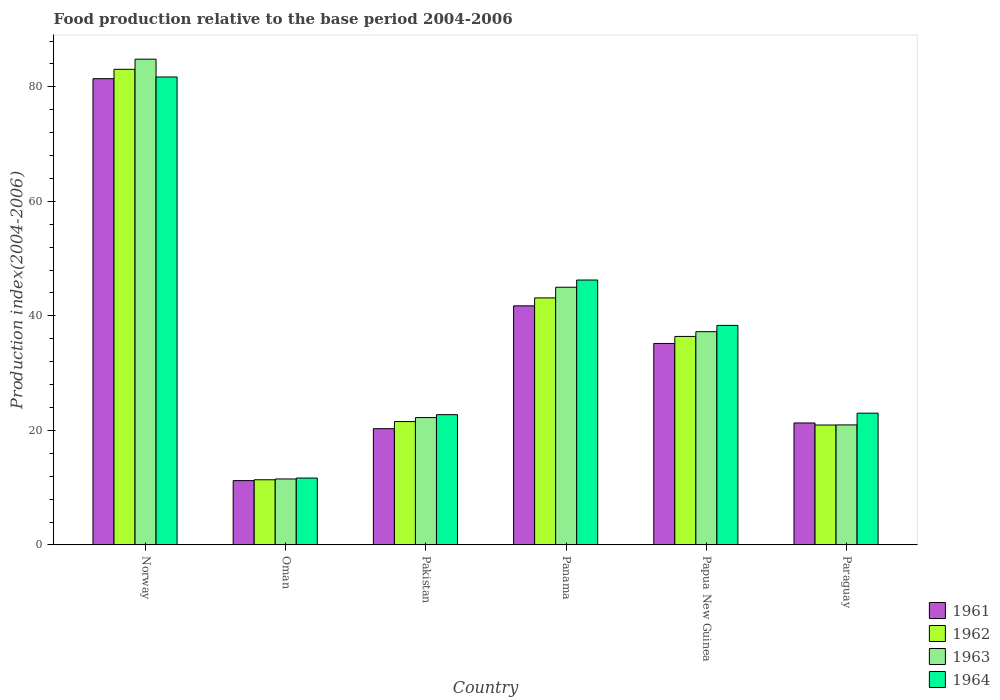How many groups of bars are there?
Make the answer very short. 6. Are the number of bars per tick equal to the number of legend labels?
Make the answer very short. Yes. Are the number of bars on each tick of the X-axis equal?
Offer a terse response. Yes. How many bars are there on the 6th tick from the right?
Provide a succinct answer. 4. In how many cases, is the number of bars for a given country not equal to the number of legend labels?
Your response must be concise. 0. What is the food production index in 1963 in Pakistan?
Give a very brief answer. 22.24. Across all countries, what is the maximum food production index in 1962?
Your response must be concise. 83.06. Across all countries, what is the minimum food production index in 1963?
Give a very brief answer. 11.52. In which country was the food production index in 1964 minimum?
Provide a succinct answer. Oman. What is the total food production index in 1964 in the graph?
Offer a terse response. 223.76. What is the difference between the food production index in 1961 in Norway and that in Panama?
Keep it short and to the point. 39.67. What is the difference between the food production index in 1963 in Papua New Guinea and the food production index in 1961 in Norway?
Ensure brevity in your answer.  -44.18. What is the average food production index in 1963 per country?
Your answer should be compact. 36.96. What is the difference between the food production index of/in 1962 and food production index of/in 1963 in Papua New Guinea?
Keep it short and to the point. -0.83. In how many countries, is the food production index in 1963 greater than 72?
Offer a very short reply. 1. What is the ratio of the food production index in 1964 in Pakistan to that in Paraguay?
Make the answer very short. 0.99. What is the difference between the highest and the second highest food production index in 1964?
Give a very brief answer. -43.38. What is the difference between the highest and the lowest food production index in 1964?
Offer a terse response. 70.04. In how many countries, is the food production index in 1964 greater than the average food production index in 1964 taken over all countries?
Your response must be concise. 3. Is it the case that in every country, the sum of the food production index in 1962 and food production index in 1963 is greater than the sum of food production index in 1961 and food production index in 1964?
Provide a succinct answer. No. What does the 1st bar from the left in Pakistan represents?
Your answer should be very brief. 1961. Is it the case that in every country, the sum of the food production index in 1963 and food production index in 1962 is greater than the food production index in 1961?
Make the answer very short. Yes. Are the values on the major ticks of Y-axis written in scientific E-notation?
Ensure brevity in your answer.  No. How are the legend labels stacked?
Ensure brevity in your answer.  Vertical. What is the title of the graph?
Offer a terse response. Food production relative to the base period 2004-2006. What is the label or title of the Y-axis?
Give a very brief answer. Production index(2004-2006). What is the Production index(2004-2006) in 1961 in Norway?
Offer a terse response. 81.42. What is the Production index(2004-2006) in 1962 in Norway?
Provide a succinct answer. 83.06. What is the Production index(2004-2006) in 1963 in Norway?
Keep it short and to the point. 84.83. What is the Production index(2004-2006) of 1964 in Norway?
Ensure brevity in your answer.  81.72. What is the Production index(2004-2006) in 1961 in Oman?
Give a very brief answer. 11.23. What is the Production index(2004-2006) of 1962 in Oman?
Offer a very short reply. 11.38. What is the Production index(2004-2006) of 1963 in Oman?
Your answer should be very brief. 11.52. What is the Production index(2004-2006) of 1964 in Oman?
Provide a succinct answer. 11.68. What is the Production index(2004-2006) of 1961 in Pakistan?
Provide a succinct answer. 20.3. What is the Production index(2004-2006) in 1962 in Pakistan?
Keep it short and to the point. 21.54. What is the Production index(2004-2006) of 1963 in Pakistan?
Provide a short and direct response. 22.24. What is the Production index(2004-2006) of 1964 in Pakistan?
Keep it short and to the point. 22.75. What is the Production index(2004-2006) of 1961 in Panama?
Provide a short and direct response. 41.75. What is the Production index(2004-2006) of 1962 in Panama?
Your response must be concise. 43.14. What is the Production index(2004-2006) of 1963 in Panama?
Provide a short and direct response. 45. What is the Production index(2004-2006) of 1964 in Panama?
Your answer should be compact. 46.26. What is the Production index(2004-2006) of 1961 in Papua New Guinea?
Provide a short and direct response. 35.18. What is the Production index(2004-2006) in 1962 in Papua New Guinea?
Make the answer very short. 36.41. What is the Production index(2004-2006) of 1963 in Papua New Guinea?
Your response must be concise. 37.24. What is the Production index(2004-2006) of 1964 in Papua New Guinea?
Your answer should be compact. 38.34. What is the Production index(2004-2006) in 1961 in Paraguay?
Give a very brief answer. 21.3. What is the Production index(2004-2006) in 1962 in Paraguay?
Provide a short and direct response. 20.94. What is the Production index(2004-2006) of 1963 in Paraguay?
Ensure brevity in your answer.  20.96. What is the Production index(2004-2006) in 1964 in Paraguay?
Provide a succinct answer. 23.01. Across all countries, what is the maximum Production index(2004-2006) in 1961?
Offer a very short reply. 81.42. Across all countries, what is the maximum Production index(2004-2006) of 1962?
Your answer should be very brief. 83.06. Across all countries, what is the maximum Production index(2004-2006) in 1963?
Give a very brief answer. 84.83. Across all countries, what is the maximum Production index(2004-2006) in 1964?
Offer a very short reply. 81.72. Across all countries, what is the minimum Production index(2004-2006) of 1961?
Offer a very short reply. 11.23. Across all countries, what is the minimum Production index(2004-2006) in 1962?
Ensure brevity in your answer.  11.38. Across all countries, what is the minimum Production index(2004-2006) of 1963?
Your response must be concise. 11.52. Across all countries, what is the minimum Production index(2004-2006) in 1964?
Make the answer very short. 11.68. What is the total Production index(2004-2006) of 1961 in the graph?
Your answer should be compact. 211.18. What is the total Production index(2004-2006) in 1962 in the graph?
Keep it short and to the point. 216.47. What is the total Production index(2004-2006) in 1963 in the graph?
Offer a terse response. 221.79. What is the total Production index(2004-2006) of 1964 in the graph?
Your answer should be very brief. 223.76. What is the difference between the Production index(2004-2006) of 1961 in Norway and that in Oman?
Ensure brevity in your answer.  70.19. What is the difference between the Production index(2004-2006) of 1962 in Norway and that in Oman?
Provide a succinct answer. 71.68. What is the difference between the Production index(2004-2006) in 1963 in Norway and that in Oman?
Keep it short and to the point. 73.31. What is the difference between the Production index(2004-2006) of 1964 in Norway and that in Oman?
Offer a very short reply. 70.04. What is the difference between the Production index(2004-2006) of 1961 in Norway and that in Pakistan?
Provide a succinct answer. 61.12. What is the difference between the Production index(2004-2006) in 1962 in Norway and that in Pakistan?
Your answer should be compact. 61.52. What is the difference between the Production index(2004-2006) of 1963 in Norway and that in Pakistan?
Provide a succinct answer. 62.59. What is the difference between the Production index(2004-2006) of 1964 in Norway and that in Pakistan?
Provide a succinct answer. 58.97. What is the difference between the Production index(2004-2006) of 1961 in Norway and that in Panama?
Keep it short and to the point. 39.67. What is the difference between the Production index(2004-2006) of 1962 in Norway and that in Panama?
Give a very brief answer. 39.92. What is the difference between the Production index(2004-2006) of 1963 in Norway and that in Panama?
Ensure brevity in your answer.  39.83. What is the difference between the Production index(2004-2006) in 1964 in Norway and that in Panama?
Provide a succinct answer. 35.46. What is the difference between the Production index(2004-2006) in 1961 in Norway and that in Papua New Guinea?
Provide a short and direct response. 46.24. What is the difference between the Production index(2004-2006) in 1962 in Norway and that in Papua New Guinea?
Ensure brevity in your answer.  46.65. What is the difference between the Production index(2004-2006) in 1963 in Norway and that in Papua New Guinea?
Make the answer very short. 47.59. What is the difference between the Production index(2004-2006) of 1964 in Norway and that in Papua New Guinea?
Offer a very short reply. 43.38. What is the difference between the Production index(2004-2006) of 1961 in Norway and that in Paraguay?
Offer a terse response. 60.12. What is the difference between the Production index(2004-2006) of 1962 in Norway and that in Paraguay?
Offer a very short reply. 62.12. What is the difference between the Production index(2004-2006) of 1963 in Norway and that in Paraguay?
Keep it short and to the point. 63.87. What is the difference between the Production index(2004-2006) of 1964 in Norway and that in Paraguay?
Your response must be concise. 58.71. What is the difference between the Production index(2004-2006) in 1961 in Oman and that in Pakistan?
Your answer should be very brief. -9.07. What is the difference between the Production index(2004-2006) of 1962 in Oman and that in Pakistan?
Provide a short and direct response. -10.16. What is the difference between the Production index(2004-2006) of 1963 in Oman and that in Pakistan?
Your answer should be very brief. -10.72. What is the difference between the Production index(2004-2006) in 1964 in Oman and that in Pakistan?
Offer a terse response. -11.07. What is the difference between the Production index(2004-2006) in 1961 in Oman and that in Panama?
Provide a short and direct response. -30.52. What is the difference between the Production index(2004-2006) in 1962 in Oman and that in Panama?
Your response must be concise. -31.76. What is the difference between the Production index(2004-2006) of 1963 in Oman and that in Panama?
Offer a terse response. -33.48. What is the difference between the Production index(2004-2006) in 1964 in Oman and that in Panama?
Provide a short and direct response. -34.58. What is the difference between the Production index(2004-2006) in 1961 in Oman and that in Papua New Guinea?
Ensure brevity in your answer.  -23.95. What is the difference between the Production index(2004-2006) in 1962 in Oman and that in Papua New Guinea?
Offer a very short reply. -25.03. What is the difference between the Production index(2004-2006) in 1963 in Oman and that in Papua New Guinea?
Your answer should be compact. -25.72. What is the difference between the Production index(2004-2006) in 1964 in Oman and that in Papua New Guinea?
Your answer should be very brief. -26.66. What is the difference between the Production index(2004-2006) in 1961 in Oman and that in Paraguay?
Your answer should be very brief. -10.07. What is the difference between the Production index(2004-2006) in 1962 in Oman and that in Paraguay?
Ensure brevity in your answer.  -9.56. What is the difference between the Production index(2004-2006) in 1963 in Oman and that in Paraguay?
Your answer should be very brief. -9.44. What is the difference between the Production index(2004-2006) of 1964 in Oman and that in Paraguay?
Keep it short and to the point. -11.33. What is the difference between the Production index(2004-2006) of 1961 in Pakistan and that in Panama?
Provide a short and direct response. -21.45. What is the difference between the Production index(2004-2006) in 1962 in Pakistan and that in Panama?
Keep it short and to the point. -21.6. What is the difference between the Production index(2004-2006) of 1963 in Pakistan and that in Panama?
Offer a terse response. -22.76. What is the difference between the Production index(2004-2006) in 1964 in Pakistan and that in Panama?
Give a very brief answer. -23.51. What is the difference between the Production index(2004-2006) of 1961 in Pakistan and that in Papua New Guinea?
Keep it short and to the point. -14.88. What is the difference between the Production index(2004-2006) of 1962 in Pakistan and that in Papua New Guinea?
Your answer should be compact. -14.87. What is the difference between the Production index(2004-2006) in 1964 in Pakistan and that in Papua New Guinea?
Your answer should be compact. -15.59. What is the difference between the Production index(2004-2006) of 1961 in Pakistan and that in Paraguay?
Keep it short and to the point. -1. What is the difference between the Production index(2004-2006) of 1962 in Pakistan and that in Paraguay?
Give a very brief answer. 0.6. What is the difference between the Production index(2004-2006) of 1963 in Pakistan and that in Paraguay?
Offer a very short reply. 1.28. What is the difference between the Production index(2004-2006) of 1964 in Pakistan and that in Paraguay?
Your response must be concise. -0.26. What is the difference between the Production index(2004-2006) in 1961 in Panama and that in Papua New Guinea?
Your response must be concise. 6.57. What is the difference between the Production index(2004-2006) in 1962 in Panama and that in Papua New Guinea?
Offer a terse response. 6.73. What is the difference between the Production index(2004-2006) of 1963 in Panama and that in Papua New Guinea?
Make the answer very short. 7.76. What is the difference between the Production index(2004-2006) in 1964 in Panama and that in Papua New Guinea?
Provide a succinct answer. 7.92. What is the difference between the Production index(2004-2006) of 1961 in Panama and that in Paraguay?
Your answer should be very brief. 20.45. What is the difference between the Production index(2004-2006) in 1962 in Panama and that in Paraguay?
Make the answer very short. 22.2. What is the difference between the Production index(2004-2006) in 1963 in Panama and that in Paraguay?
Provide a succinct answer. 24.04. What is the difference between the Production index(2004-2006) in 1964 in Panama and that in Paraguay?
Provide a short and direct response. 23.25. What is the difference between the Production index(2004-2006) in 1961 in Papua New Guinea and that in Paraguay?
Your answer should be very brief. 13.88. What is the difference between the Production index(2004-2006) of 1962 in Papua New Guinea and that in Paraguay?
Make the answer very short. 15.47. What is the difference between the Production index(2004-2006) of 1963 in Papua New Guinea and that in Paraguay?
Offer a terse response. 16.28. What is the difference between the Production index(2004-2006) of 1964 in Papua New Guinea and that in Paraguay?
Your response must be concise. 15.33. What is the difference between the Production index(2004-2006) of 1961 in Norway and the Production index(2004-2006) of 1962 in Oman?
Ensure brevity in your answer.  70.04. What is the difference between the Production index(2004-2006) of 1961 in Norway and the Production index(2004-2006) of 1963 in Oman?
Provide a short and direct response. 69.9. What is the difference between the Production index(2004-2006) in 1961 in Norway and the Production index(2004-2006) in 1964 in Oman?
Ensure brevity in your answer.  69.74. What is the difference between the Production index(2004-2006) in 1962 in Norway and the Production index(2004-2006) in 1963 in Oman?
Your response must be concise. 71.54. What is the difference between the Production index(2004-2006) of 1962 in Norway and the Production index(2004-2006) of 1964 in Oman?
Your answer should be compact. 71.38. What is the difference between the Production index(2004-2006) of 1963 in Norway and the Production index(2004-2006) of 1964 in Oman?
Provide a short and direct response. 73.15. What is the difference between the Production index(2004-2006) in 1961 in Norway and the Production index(2004-2006) in 1962 in Pakistan?
Offer a terse response. 59.88. What is the difference between the Production index(2004-2006) in 1961 in Norway and the Production index(2004-2006) in 1963 in Pakistan?
Keep it short and to the point. 59.18. What is the difference between the Production index(2004-2006) in 1961 in Norway and the Production index(2004-2006) in 1964 in Pakistan?
Ensure brevity in your answer.  58.67. What is the difference between the Production index(2004-2006) of 1962 in Norway and the Production index(2004-2006) of 1963 in Pakistan?
Ensure brevity in your answer.  60.82. What is the difference between the Production index(2004-2006) in 1962 in Norway and the Production index(2004-2006) in 1964 in Pakistan?
Keep it short and to the point. 60.31. What is the difference between the Production index(2004-2006) in 1963 in Norway and the Production index(2004-2006) in 1964 in Pakistan?
Offer a terse response. 62.08. What is the difference between the Production index(2004-2006) in 1961 in Norway and the Production index(2004-2006) in 1962 in Panama?
Your answer should be very brief. 38.28. What is the difference between the Production index(2004-2006) of 1961 in Norway and the Production index(2004-2006) of 1963 in Panama?
Your response must be concise. 36.42. What is the difference between the Production index(2004-2006) of 1961 in Norway and the Production index(2004-2006) of 1964 in Panama?
Ensure brevity in your answer.  35.16. What is the difference between the Production index(2004-2006) of 1962 in Norway and the Production index(2004-2006) of 1963 in Panama?
Ensure brevity in your answer.  38.06. What is the difference between the Production index(2004-2006) in 1962 in Norway and the Production index(2004-2006) in 1964 in Panama?
Your answer should be compact. 36.8. What is the difference between the Production index(2004-2006) in 1963 in Norway and the Production index(2004-2006) in 1964 in Panama?
Your answer should be very brief. 38.57. What is the difference between the Production index(2004-2006) of 1961 in Norway and the Production index(2004-2006) of 1962 in Papua New Guinea?
Your answer should be very brief. 45.01. What is the difference between the Production index(2004-2006) in 1961 in Norway and the Production index(2004-2006) in 1963 in Papua New Guinea?
Your response must be concise. 44.18. What is the difference between the Production index(2004-2006) in 1961 in Norway and the Production index(2004-2006) in 1964 in Papua New Guinea?
Make the answer very short. 43.08. What is the difference between the Production index(2004-2006) of 1962 in Norway and the Production index(2004-2006) of 1963 in Papua New Guinea?
Provide a short and direct response. 45.82. What is the difference between the Production index(2004-2006) of 1962 in Norway and the Production index(2004-2006) of 1964 in Papua New Guinea?
Provide a succinct answer. 44.72. What is the difference between the Production index(2004-2006) of 1963 in Norway and the Production index(2004-2006) of 1964 in Papua New Guinea?
Keep it short and to the point. 46.49. What is the difference between the Production index(2004-2006) in 1961 in Norway and the Production index(2004-2006) in 1962 in Paraguay?
Your response must be concise. 60.48. What is the difference between the Production index(2004-2006) in 1961 in Norway and the Production index(2004-2006) in 1963 in Paraguay?
Your answer should be compact. 60.46. What is the difference between the Production index(2004-2006) in 1961 in Norway and the Production index(2004-2006) in 1964 in Paraguay?
Provide a short and direct response. 58.41. What is the difference between the Production index(2004-2006) in 1962 in Norway and the Production index(2004-2006) in 1963 in Paraguay?
Provide a short and direct response. 62.1. What is the difference between the Production index(2004-2006) of 1962 in Norway and the Production index(2004-2006) of 1964 in Paraguay?
Your answer should be very brief. 60.05. What is the difference between the Production index(2004-2006) in 1963 in Norway and the Production index(2004-2006) in 1964 in Paraguay?
Give a very brief answer. 61.82. What is the difference between the Production index(2004-2006) of 1961 in Oman and the Production index(2004-2006) of 1962 in Pakistan?
Your response must be concise. -10.31. What is the difference between the Production index(2004-2006) of 1961 in Oman and the Production index(2004-2006) of 1963 in Pakistan?
Your answer should be very brief. -11.01. What is the difference between the Production index(2004-2006) in 1961 in Oman and the Production index(2004-2006) in 1964 in Pakistan?
Provide a short and direct response. -11.52. What is the difference between the Production index(2004-2006) in 1962 in Oman and the Production index(2004-2006) in 1963 in Pakistan?
Provide a succinct answer. -10.86. What is the difference between the Production index(2004-2006) of 1962 in Oman and the Production index(2004-2006) of 1964 in Pakistan?
Keep it short and to the point. -11.37. What is the difference between the Production index(2004-2006) of 1963 in Oman and the Production index(2004-2006) of 1964 in Pakistan?
Offer a very short reply. -11.23. What is the difference between the Production index(2004-2006) in 1961 in Oman and the Production index(2004-2006) in 1962 in Panama?
Your response must be concise. -31.91. What is the difference between the Production index(2004-2006) in 1961 in Oman and the Production index(2004-2006) in 1963 in Panama?
Provide a short and direct response. -33.77. What is the difference between the Production index(2004-2006) in 1961 in Oman and the Production index(2004-2006) in 1964 in Panama?
Provide a succinct answer. -35.03. What is the difference between the Production index(2004-2006) of 1962 in Oman and the Production index(2004-2006) of 1963 in Panama?
Give a very brief answer. -33.62. What is the difference between the Production index(2004-2006) in 1962 in Oman and the Production index(2004-2006) in 1964 in Panama?
Provide a succinct answer. -34.88. What is the difference between the Production index(2004-2006) in 1963 in Oman and the Production index(2004-2006) in 1964 in Panama?
Make the answer very short. -34.74. What is the difference between the Production index(2004-2006) in 1961 in Oman and the Production index(2004-2006) in 1962 in Papua New Guinea?
Offer a very short reply. -25.18. What is the difference between the Production index(2004-2006) in 1961 in Oman and the Production index(2004-2006) in 1963 in Papua New Guinea?
Your answer should be very brief. -26.01. What is the difference between the Production index(2004-2006) in 1961 in Oman and the Production index(2004-2006) in 1964 in Papua New Guinea?
Make the answer very short. -27.11. What is the difference between the Production index(2004-2006) in 1962 in Oman and the Production index(2004-2006) in 1963 in Papua New Guinea?
Make the answer very short. -25.86. What is the difference between the Production index(2004-2006) of 1962 in Oman and the Production index(2004-2006) of 1964 in Papua New Guinea?
Keep it short and to the point. -26.96. What is the difference between the Production index(2004-2006) of 1963 in Oman and the Production index(2004-2006) of 1964 in Papua New Guinea?
Offer a very short reply. -26.82. What is the difference between the Production index(2004-2006) in 1961 in Oman and the Production index(2004-2006) in 1962 in Paraguay?
Offer a terse response. -9.71. What is the difference between the Production index(2004-2006) of 1961 in Oman and the Production index(2004-2006) of 1963 in Paraguay?
Offer a very short reply. -9.73. What is the difference between the Production index(2004-2006) of 1961 in Oman and the Production index(2004-2006) of 1964 in Paraguay?
Give a very brief answer. -11.78. What is the difference between the Production index(2004-2006) of 1962 in Oman and the Production index(2004-2006) of 1963 in Paraguay?
Give a very brief answer. -9.58. What is the difference between the Production index(2004-2006) in 1962 in Oman and the Production index(2004-2006) in 1964 in Paraguay?
Provide a short and direct response. -11.63. What is the difference between the Production index(2004-2006) in 1963 in Oman and the Production index(2004-2006) in 1964 in Paraguay?
Provide a succinct answer. -11.49. What is the difference between the Production index(2004-2006) in 1961 in Pakistan and the Production index(2004-2006) in 1962 in Panama?
Ensure brevity in your answer.  -22.84. What is the difference between the Production index(2004-2006) in 1961 in Pakistan and the Production index(2004-2006) in 1963 in Panama?
Provide a succinct answer. -24.7. What is the difference between the Production index(2004-2006) of 1961 in Pakistan and the Production index(2004-2006) of 1964 in Panama?
Provide a short and direct response. -25.96. What is the difference between the Production index(2004-2006) in 1962 in Pakistan and the Production index(2004-2006) in 1963 in Panama?
Give a very brief answer. -23.46. What is the difference between the Production index(2004-2006) in 1962 in Pakistan and the Production index(2004-2006) in 1964 in Panama?
Your answer should be very brief. -24.72. What is the difference between the Production index(2004-2006) in 1963 in Pakistan and the Production index(2004-2006) in 1964 in Panama?
Your response must be concise. -24.02. What is the difference between the Production index(2004-2006) in 1961 in Pakistan and the Production index(2004-2006) in 1962 in Papua New Guinea?
Keep it short and to the point. -16.11. What is the difference between the Production index(2004-2006) of 1961 in Pakistan and the Production index(2004-2006) of 1963 in Papua New Guinea?
Provide a short and direct response. -16.94. What is the difference between the Production index(2004-2006) in 1961 in Pakistan and the Production index(2004-2006) in 1964 in Papua New Guinea?
Provide a succinct answer. -18.04. What is the difference between the Production index(2004-2006) in 1962 in Pakistan and the Production index(2004-2006) in 1963 in Papua New Guinea?
Ensure brevity in your answer.  -15.7. What is the difference between the Production index(2004-2006) of 1962 in Pakistan and the Production index(2004-2006) of 1964 in Papua New Guinea?
Offer a very short reply. -16.8. What is the difference between the Production index(2004-2006) in 1963 in Pakistan and the Production index(2004-2006) in 1964 in Papua New Guinea?
Give a very brief answer. -16.1. What is the difference between the Production index(2004-2006) of 1961 in Pakistan and the Production index(2004-2006) of 1962 in Paraguay?
Provide a short and direct response. -0.64. What is the difference between the Production index(2004-2006) in 1961 in Pakistan and the Production index(2004-2006) in 1963 in Paraguay?
Your answer should be very brief. -0.66. What is the difference between the Production index(2004-2006) of 1961 in Pakistan and the Production index(2004-2006) of 1964 in Paraguay?
Provide a short and direct response. -2.71. What is the difference between the Production index(2004-2006) in 1962 in Pakistan and the Production index(2004-2006) in 1963 in Paraguay?
Your response must be concise. 0.58. What is the difference between the Production index(2004-2006) of 1962 in Pakistan and the Production index(2004-2006) of 1964 in Paraguay?
Keep it short and to the point. -1.47. What is the difference between the Production index(2004-2006) of 1963 in Pakistan and the Production index(2004-2006) of 1964 in Paraguay?
Provide a succinct answer. -0.77. What is the difference between the Production index(2004-2006) of 1961 in Panama and the Production index(2004-2006) of 1962 in Papua New Guinea?
Keep it short and to the point. 5.34. What is the difference between the Production index(2004-2006) of 1961 in Panama and the Production index(2004-2006) of 1963 in Papua New Guinea?
Provide a succinct answer. 4.51. What is the difference between the Production index(2004-2006) of 1961 in Panama and the Production index(2004-2006) of 1964 in Papua New Guinea?
Your answer should be compact. 3.41. What is the difference between the Production index(2004-2006) of 1962 in Panama and the Production index(2004-2006) of 1964 in Papua New Guinea?
Provide a short and direct response. 4.8. What is the difference between the Production index(2004-2006) in 1963 in Panama and the Production index(2004-2006) in 1964 in Papua New Guinea?
Provide a short and direct response. 6.66. What is the difference between the Production index(2004-2006) in 1961 in Panama and the Production index(2004-2006) in 1962 in Paraguay?
Your response must be concise. 20.81. What is the difference between the Production index(2004-2006) of 1961 in Panama and the Production index(2004-2006) of 1963 in Paraguay?
Provide a succinct answer. 20.79. What is the difference between the Production index(2004-2006) of 1961 in Panama and the Production index(2004-2006) of 1964 in Paraguay?
Give a very brief answer. 18.74. What is the difference between the Production index(2004-2006) of 1962 in Panama and the Production index(2004-2006) of 1963 in Paraguay?
Keep it short and to the point. 22.18. What is the difference between the Production index(2004-2006) of 1962 in Panama and the Production index(2004-2006) of 1964 in Paraguay?
Offer a very short reply. 20.13. What is the difference between the Production index(2004-2006) in 1963 in Panama and the Production index(2004-2006) in 1964 in Paraguay?
Give a very brief answer. 21.99. What is the difference between the Production index(2004-2006) in 1961 in Papua New Guinea and the Production index(2004-2006) in 1962 in Paraguay?
Make the answer very short. 14.24. What is the difference between the Production index(2004-2006) in 1961 in Papua New Guinea and the Production index(2004-2006) in 1963 in Paraguay?
Your answer should be very brief. 14.22. What is the difference between the Production index(2004-2006) of 1961 in Papua New Guinea and the Production index(2004-2006) of 1964 in Paraguay?
Provide a short and direct response. 12.17. What is the difference between the Production index(2004-2006) of 1962 in Papua New Guinea and the Production index(2004-2006) of 1963 in Paraguay?
Offer a very short reply. 15.45. What is the difference between the Production index(2004-2006) of 1963 in Papua New Guinea and the Production index(2004-2006) of 1964 in Paraguay?
Give a very brief answer. 14.23. What is the average Production index(2004-2006) in 1961 per country?
Make the answer very short. 35.2. What is the average Production index(2004-2006) in 1962 per country?
Your answer should be very brief. 36.08. What is the average Production index(2004-2006) in 1963 per country?
Your answer should be compact. 36.97. What is the average Production index(2004-2006) of 1964 per country?
Offer a very short reply. 37.29. What is the difference between the Production index(2004-2006) of 1961 and Production index(2004-2006) of 1962 in Norway?
Provide a succinct answer. -1.64. What is the difference between the Production index(2004-2006) of 1961 and Production index(2004-2006) of 1963 in Norway?
Give a very brief answer. -3.41. What is the difference between the Production index(2004-2006) of 1961 and Production index(2004-2006) of 1964 in Norway?
Give a very brief answer. -0.3. What is the difference between the Production index(2004-2006) in 1962 and Production index(2004-2006) in 1963 in Norway?
Your answer should be compact. -1.77. What is the difference between the Production index(2004-2006) of 1962 and Production index(2004-2006) of 1964 in Norway?
Make the answer very short. 1.34. What is the difference between the Production index(2004-2006) of 1963 and Production index(2004-2006) of 1964 in Norway?
Ensure brevity in your answer.  3.11. What is the difference between the Production index(2004-2006) in 1961 and Production index(2004-2006) in 1963 in Oman?
Keep it short and to the point. -0.29. What is the difference between the Production index(2004-2006) in 1961 and Production index(2004-2006) in 1964 in Oman?
Offer a terse response. -0.45. What is the difference between the Production index(2004-2006) of 1962 and Production index(2004-2006) of 1963 in Oman?
Offer a very short reply. -0.14. What is the difference between the Production index(2004-2006) in 1962 and Production index(2004-2006) in 1964 in Oman?
Give a very brief answer. -0.3. What is the difference between the Production index(2004-2006) of 1963 and Production index(2004-2006) of 1964 in Oman?
Your answer should be very brief. -0.16. What is the difference between the Production index(2004-2006) in 1961 and Production index(2004-2006) in 1962 in Pakistan?
Your answer should be compact. -1.24. What is the difference between the Production index(2004-2006) in 1961 and Production index(2004-2006) in 1963 in Pakistan?
Your answer should be compact. -1.94. What is the difference between the Production index(2004-2006) in 1961 and Production index(2004-2006) in 1964 in Pakistan?
Ensure brevity in your answer.  -2.45. What is the difference between the Production index(2004-2006) in 1962 and Production index(2004-2006) in 1964 in Pakistan?
Ensure brevity in your answer.  -1.21. What is the difference between the Production index(2004-2006) of 1963 and Production index(2004-2006) of 1964 in Pakistan?
Provide a succinct answer. -0.51. What is the difference between the Production index(2004-2006) of 1961 and Production index(2004-2006) of 1962 in Panama?
Provide a succinct answer. -1.39. What is the difference between the Production index(2004-2006) of 1961 and Production index(2004-2006) of 1963 in Panama?
Your answer should be very brief. -3.25. What is the difference between the Production index(2004-2006) in 1961 and Production index(2004-2006) in 1964 in Panama?
Your answer should be very brief. -4.51. What is the difference between the Production index(2004-2006) in 1962 and Production index(2004-2006) in 1963 in Panama?
Provide a short and direct response. -1.86. What is the difference between the Production index(2004-2006) of 1962 and Production index(2004-2006) of 1964 in Panama?
Your answer should be very brief. -3.12. What is the difference between the Production index(2004-2006) in 1963 and Production index(2004-2006) in 1964 in Panama?
Provide a short and direct response. -1.26. What is the difference between the Production index(2004-2006) in 1961 and Production index(2004-2006) in 1962 in Papua New Guinea?
Your answer should be compact. -1.23. What is the difference between the Production index(2004-2006) in 1961 and Production index(2004-2006) in 1963 in Papua New Guinea?
Ensure brevity in your answer.  -2.06. What is the difference between the Production index(2004-2006) in 1961 and Production index(2004-2006) in 1964 in Papua New Guinea?
Provide a short and direct response. -3.16. What is the difference between the Production index(2004-2006) in 1962 and Production index(2004-2006) in 1963 in Papua New Guinea?
Make the answer very short. -0.83. What is the difference between the Production index(2004-2006) of 1962 and Production index(2004-2006) of 1964 in Papua New Guinea?
Offer a terse response. -1.93. What is the difference between the Production index(2004-2006) in 1961 and Production index(2004-2006) in 1962 in Paraguay?
Keep it short and to the point. 0.36. What is the difference between the Production index(2004-2006) in 1961 and Production index(2004-2006) in 1963 in Paraguay?
Offer a terse response. 0.34. What is the difference between the Production index(2004-2006) in 1961 and Production index(2004-2006) in 1964 in Paraguay?
Give a very brief answer. -1.71. What is the difference between the Production index(2004-2006) in 1962 and Production index(2004-2006) in 1963 in Paraguay?
Offer a very short reply. -0.02. What is the difference between the Production index(2004-2006) of 1962 and Production index(2004-2006) of 1964 in Paraguay?
Provide a short and direct response. -2.07. What is the difference between the Production index(2004-2006) of 1963 and Production index(2004-2006) of 1964 in Paraguay?
Provide a short and direct response. -2.05. What is the ratio of the Production index(2004-2006) in 1961 in Norway to that in Oman?
Provide a succinct answer. 7.25. What is the ratio of the Production index(2004-2006) of 1962 in Norway to that in Oman?
Keep it short and to the point. 7.3. What is the ratio of the Production index(2004-2006) in 1963 in Norway to that in Oman?
Give a very brief answer. 7.36. What is the ratio of the Production index(2004-2006) in 1964 in Norway to that in Oman?
Make the answer very short. 7. What is the ratio of the Production index(2004-2006) in 1961 in Norway to that in Pakistan?
Make the answer very short. 4.01. What is the ratio of the Production index(2004-2006) of 1962 in Norway to that in Pakistan?
Keep it short and to the point. 3.86. What is the ratio of the Production index(2004-2006) of 1963 in Norway to that in Pakistan?
Offer a very short reply. 3.81. What is the ratio of the Production index(2004-2006) in 1964 in Norway to that in Pakistan?
Provide a succinct answer. 3.59. What is the ratio of the Production index(2004-2006) of 1961 in Norway to that in Panama?
Offer a terse response. 1.95. What is the ratio of the Production index(2004-2006) in 1962 in Norway to that in Panama?
Offer a very short reply. 1.93. What is the ratio of the Production index(2004-2006) of 1963 in Norway to that in Panama?
Offer a terse response. 1.89. What is the ratio of the Production index(2004-2006) of 1964 in Norway to that in Panama?
Your answer should be compact. 1.77. What is the ratio of the Production index(2004-2006) of 1961 in Norway to that in Papua New Guinea?
Give a very brief answer. 2.31. What is the ratio of the Production index(2004-2006) of 1962 in Norway to that in Papua New Guinea?
Provide a short and direct response. 2.28. What is the ratio of the Production index(2004-2006) in 1963 in Norway to that in Papua New Guinea?
Provide a succinct answer. 2.28. What is the ratio of the Production index(2004-2006) of 1964 in Norway to that in Papua New Guinea?
Provide a short and direct response. 2.13. What is the ratio of the Production index(2004-2006) in 1961 in Norway to that in Paraguay?
Your answer should be compact. 3.82. What is the ratio of the Production index(2004-2006) in 1962 in Norway to that in Paraguay?
Your response must be concise. 3.97. What is the ratio of the Production index(2004-2006) in 1963 in Norway to that in Paraguay?
Provide a short and direct response. 4.05. What is the ratio of the Production index(2004-2006) of 1964 in Norway to that in Paraguay?
Ensure brevity in your answer.  3.55. What is the ratio of the Production index(2004-2006) in 1961 in Oman to that in Pakistan?
Provide a succinct answer. 0.55. What is the ratio of the Production index(2004-2006) in 1962 in Oman to that in Pakistan?
Keep it short and to the point. 0.53. What is the ratio of the Production index(2004-2006) in 1963 in Oman to that in Pakistan?
Ensure brevity in your answer.  0.52. What is the ratio of the Production index(2004-2006) of 1964 in Oman to that in Pakistan?
Your response must be concise. 0.51. What is the ratio of the Production index(2004-2006) in 1961 in Oman to that in Panama?
Offer a terse response. 0.27. What is the ratio of the Production index(2004-2006) of 1962 in Oman to that in Panama?
Your answer should be very brief. 0.26. What is the ratio of the Production index(2004-2006) in 1963 in Oman to that in Panama?
Offer a very short reply. 0.26. What is the ratio of the Production index(2004-2006) of 1964 in Oman to that in Panama?
Offer a terse response. 0.25. What is the ratio of the Production index(2004-2006) in 1961 in Oman to that in Papua New Guinea?
Your answer should be compact. 0.32. What is the ratio of the Production index(2004-2006) of 1962 in Oman to that in Papua New Guinea?
Give a very brief answer. 0.31. What is the ratio of the Production index(2004-2006) in 1963 in Oman to that in Papua New Guinea?
Provide a succinct answer. 0.31. What is the ratio of the Production index(2004-2006) of 1964 in Oman to that in Papua New Guinea?
Your answer should be very brief. 0.3. What is the ratio of the Production index(2004-2006) of 1961 in Oman to that in Paraguay?
Offer a terse response. 0.53. What is the ratio of the Production index(2004-2006) in 1962 in Oman to that in Paraguay?
Your answer should be very brief. 0.54. What is the ratio of the Production index(2004-2006) in 1963 in Oman to that in Paraguay?
Keep it short and to the point. 0.55. What is the ratio of the Production index(2004-2006) of 1964 in Oman to that in Paraguay?
Keep it short and to the point. 0.51. What is the ratio of the Production index(2004-2006) of 1961 in Pakistan to that in Panama?
Give a very brief answer. 0.49. What is the ratio of the Production index(2004-2006) in 1962 in Pakistan to that in Panama?
Your answer should be very brief. 0.5. What is the ratio of the Production index(2004-2006) in 1963 in Pakistan to that in Panama?
Make the answer very short. 0.49. What is the ratio of the Production index(2004-2006) in 1964 in Pakistan to that in Panama?
Offer a very short reply. 0.49. What is the ratio of the Production index(2004-2006) in 1961 in Pakistan to that in Papua New Guinea?
Offer a terse response. 0.58. What is the ratio of the Production index(2004-2006) of 1962 in Pakistan to that in Papua New Guinea?
Provide a succinct answer. 0.59. What is the ratio of the Production index(2004-2006) of 1963 in Pakistan to that in Papua New Guinea?
Keep it short and to the point. 0.6. What is the ratio of the Production index(2004-2006) of 1964 in Pakistan to that in Papua New Guinea?
Your answer should be very brief. 0.59. What is the ratio of the Production index(2004-2006) in 1961 in Pakistan to that in Paraguay?
Keep it short and to the point. 0.95. What is the ratio of the Production index(2004-2006) in 1962 in Pakistan to that in Paraguay?
Make the answer very short. 1.03. What is the ratio of the Production index(2004-2006) in 1963 in Pakistan to that in Paraguay?
Provide a succinct answer. 1.06. What is the ratio of the Production index(2004-2006) of 1964 in Pakistan to that in Paraguay?
Your response must be concise. 0.99. What is the ratio of the Production index(2004-2006) in 1961 in Panama to that in Papua New Guinea?
Make the answer very short. 1.19. What is the ratio of the Production index(2004-2006) in 1962 in Panama to that in Papua New Guinea?
Make the answer very short. 1.18. What is the ratio of the Production index(2004-2006) in 1963 in Panama to that in Papua New Guinea?
Keep it short and to the point. 1.21. What is the ratio of the Production index(2004-2006) in 1964 in Panama to that in Papua New Guinea?
Offer a terse response. 1.21. What is the ratio of the Production index(2004-2006) in 1961 in Panama to that in Paraguay?
Your response must be concise. 1.96. What is the ratio of the Production index(2004-2006) in 1962 in Panama to that in Paraguay?
Provide a succinct answer. 2.06. What is the ratio of the Production index(2004-2006) of 1963 in Panama to that in Paraguay?
Make the answer very short. 2.15. What is the ratio of the Production index(2004-2006) in 1964 in Panama to that in Paraguay?
Offer a terse response. 2.01. What is the ratio of the Production index(2004-2006) of 1961 in Papua New Guinea to that in Paraguay?
Provide a short and direct response. 1.65. What is the ratio of the Production index(2004-2006) of 1962 in Papua New Guinea to that in Paraguay?
Your response must be concise. 1.74. What is the ratio of the Production index(2004-2006) of 1963 in Papua New Guinea to that in Paraguay?
Offer a very short reply. 1.78. What is the ratio of the Production index(2004-2006) in 1964 in Papua New Guinea to that in Paraguay?
Your response must be concise. 1.67. What is the difference between the highest and the second highest Production index(2004-2006) of 1961?
Your response must be concise. 39.67. What is the difference between the highest and the second highest Production index(2004-2006) of 1962?
Give a very brief answer. 39.92. What is the difference between the highest and the second highest Production index(2004-2006) of 1963?
Your answer should be compact. 39.83. What is the difference between the highest and the second highest Production index(2004-2006) of 1964?
Keep it short and to the point. 35.46. What is the difference between the highest and the lowest Production index(2004-2006) of 1961?
Your response must be concise. 70.19. What is the difference between the highest and the lowest Production index(2004-2006) of 1962?
Provide a short and direct response. 71.68. What is the difference between the highest and the lowest Production index(2004-2006) of 1963?
Keep it short and to the point. 73.31. What is the difference between the highest and the lowest Production index(2004-2006) in 1964?
Offer a very short reply. 70.04. 